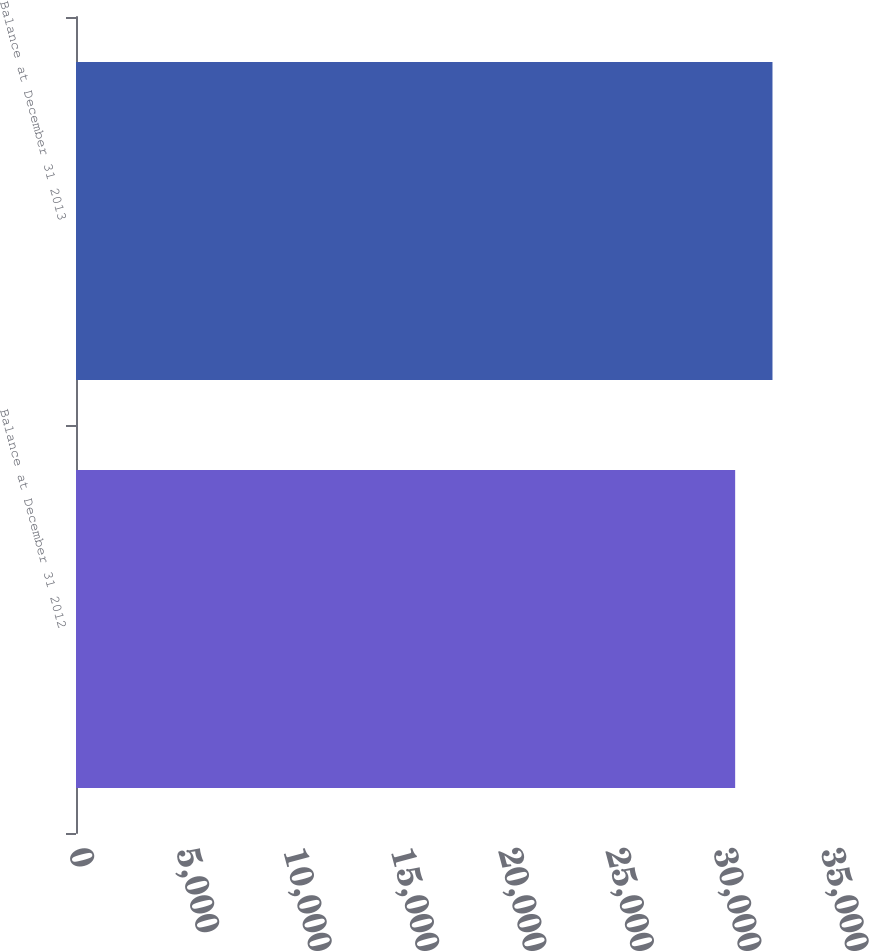Convert chart to OTSL. <chart><loc_0><loc_0><loc_500><loc_500><bar_chart><fcel>Balance at December 31 2012<fcel>Balance at December 31 2013<nl><fcel>30679<fcel>32416<nl></chart> 